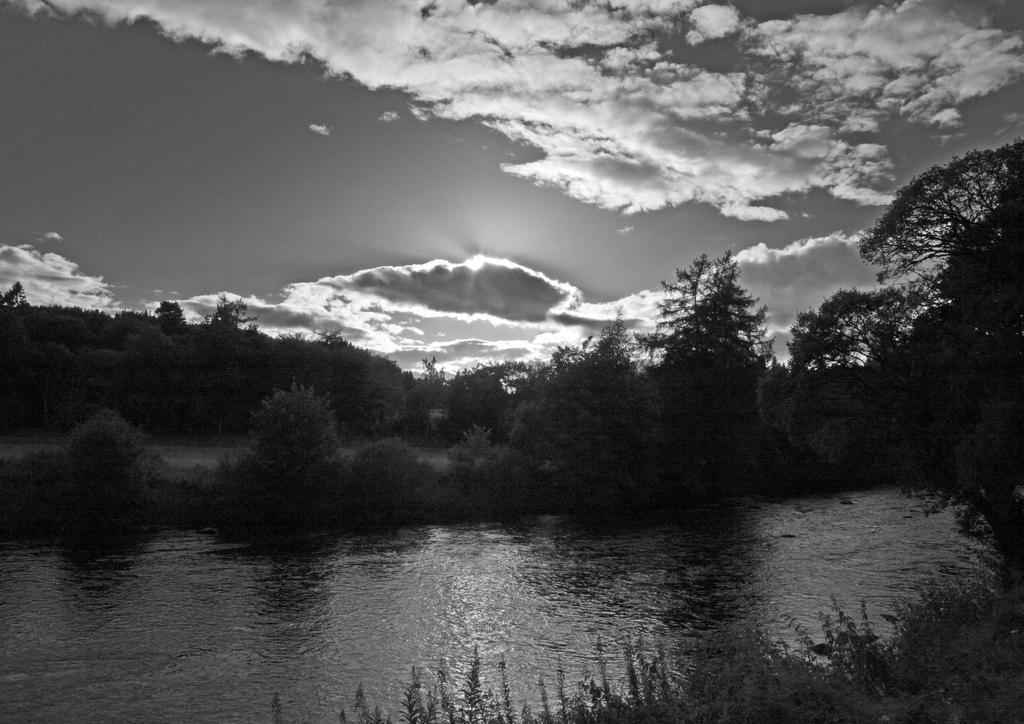Could you give a brief overview of what you see in this image? This is a black and white image and here we can see trees and at the top, there is sunset and we can see clouds in the sky. At the bottom, there is water. 